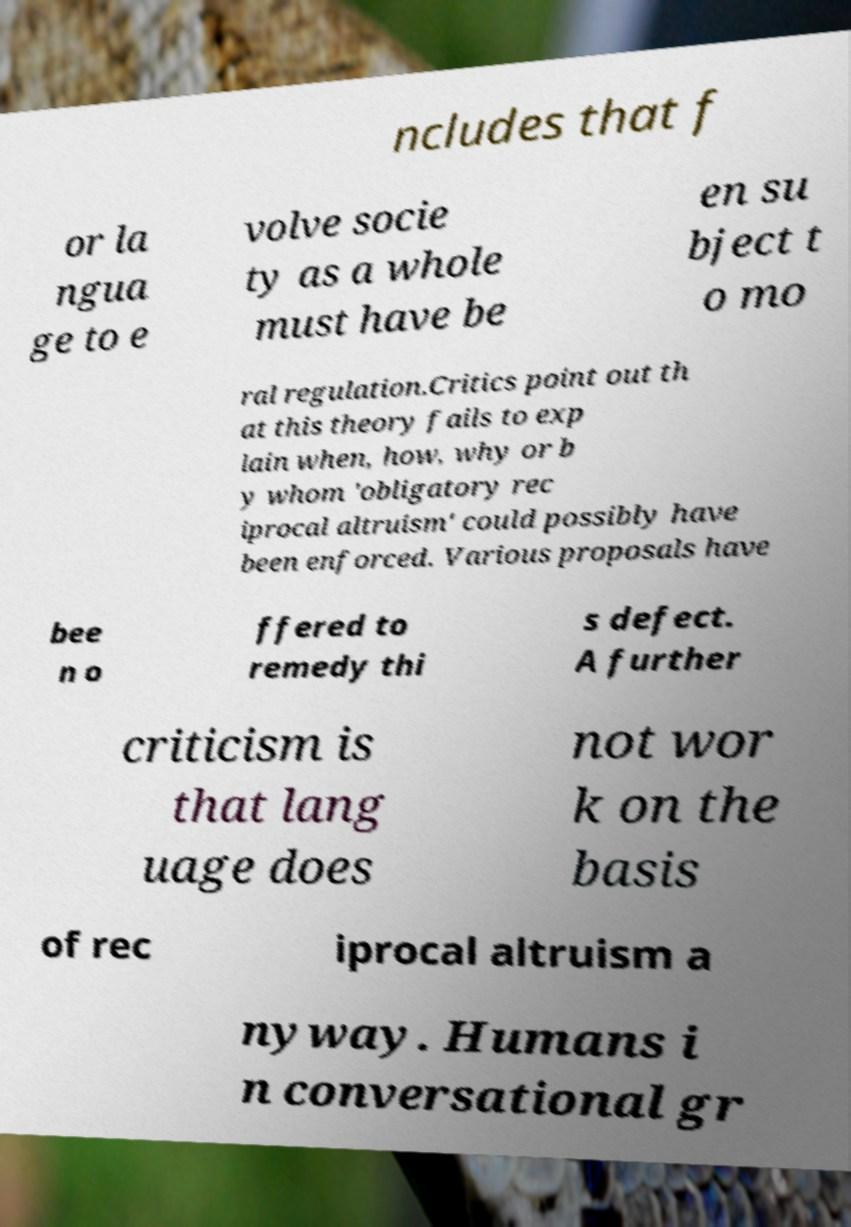Can you read and provide the text displayed in the image?This photo seems to have some interesting text. Can you extract and type it out for me? ncludes that f or la ngua ge to e volve socie ty as a whole must have be en su bject t o mo ral regulation.Critics point out th at this theory fails to exp lain when, how, why or b y whom 'obligatory rec iprocal altruism' could possibly have been enforced. Various proposals have bee n o ffered to remedy thi s defect. A further criticism is that lang uage does not wor k on the basis of rec iprocal altruism a nyway. Humans i n conversational gr 